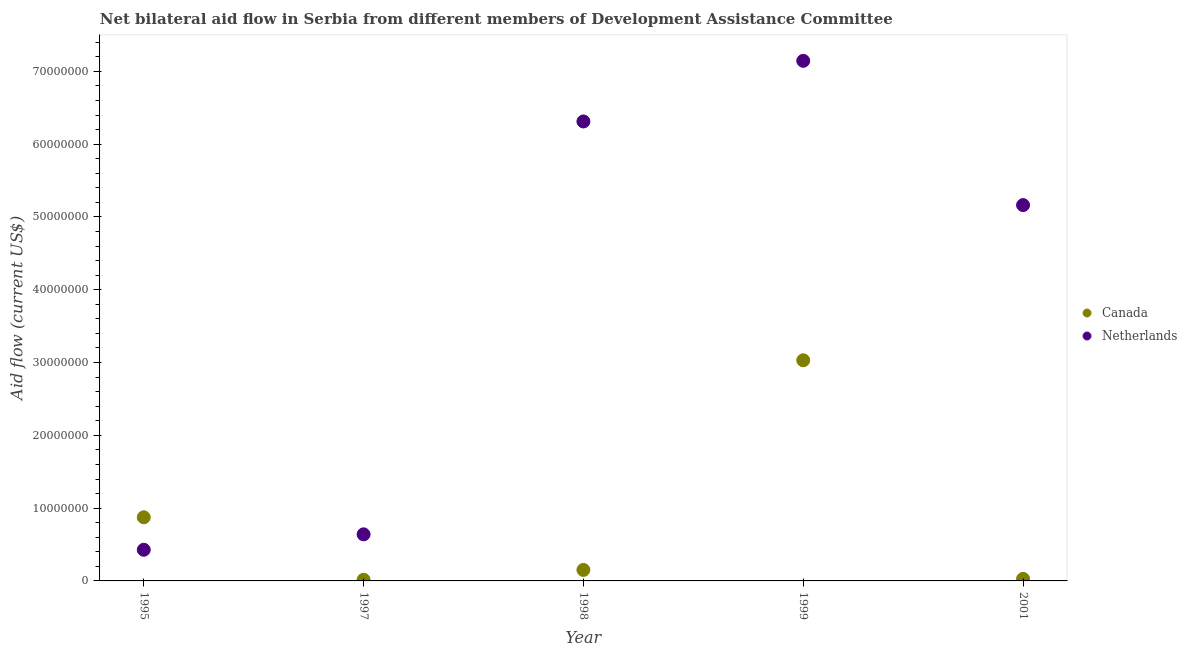How many different coloured dotlines are there?
Your answer should be very brief. 2. What is the amount of aid given by canada in 2001?
Make the answer very short. 2.80e+05. Across all years, what is the maximum amount of aid given by netherlands?
Make the answer very short. 7.14e+07. Across all years, what is the minimum amount of aid given by netherlands?
Your answer should be very brief. 4.28e+06. In which year was the amount of aid given by netherlands maximum?
Offer a terse response. 1999. In which year was the amount of aid given by canada minimum?
Ensure brevity in your answer.  1997. What is the total amount of aid given by canada in the graph?
Give a very brief answer. 4.10e+07. What is the difference between the amount of aid given by canada in 1995 and that in 2001?
Give a very brief answer. 8.46e+06. What is the difference between the amount of aid given by netherlands in 1997 and the amount of aid given by canada in 1999?
Your answer should be compact. -2.39e+07. What is the average amount of aid given by canada per year?
Provide a succinct answer. 8.20e+06. In the year 1997, what is the difference between the amount of aid given by canada and amount of aid given by netherlands?
Make the answer very short. -6.24e+06. What is the ratio of the amount of aid given by canada in 1997 to that in 1999?
Give a very brief answer. 0.01. Is the difference between the amount of aid given by canada in 1997 and 2001 greater than the difference between the amount of aid given by netherlands in 1997 and 2001?
Your answer should be very brief. Yes. What is the difference between the highest and the second highest amount of aid given by netherlands?
Make the answer very short. 8.33e+06. What is the difference between the highest and the lowest amount of aid given by netherlands?
Your answer should be very brief. 6.72e+07. Is the sum of the amount of aid given by netherlands in 1995 and 1999 greater than the maximum amount of aid given by canada across all years?
Provide a short and direct response. Yes. Is the amount of aid given by netherlands strictly greater than the amount of aid given by canada over the years?
Provide a short and direct response. No. Is the amount of aid given by netherlands strictly less than the amount of aid given by canada over the years?
Provide a short and direct response. No. How many years are there in the graph?
Offer a very short reply. 5. What is the difference between two consecutive major ticks on the Y-axis?
Make the answer very short. 1.00e+07. Are the values on the major ticks of Y-axis written in scientific E-notation?
Your answer should be compact. No. Does the graph contain any zero values?
Offer a very short reply. No. Where does the legend appear in the graph?
Provide a succinct answer. Center right. What is the title of the graph?
Your response must be concise. Net bilateral aid flow in Serbia from different members of Development Assistance Committee. What is the label or title of the X-axis?
Provide a succinct answer. Year. What is the Aid flow (current US$) in Canada in 1995?
Ensure brevity in your answer.  8.74e+06. What is the Aid flow (current US$) of Netherlands in 1995?
Your response must be concise. 4.28e+06. What is the Aid flow (current US$) in Netherlands in 1997?
Offer a terse response. 6.40e+06. What is the Aid flow (current US$) of Canada in 1998?
Offer a very short reply. 1.51e+06. What is the Aid flow (current US$) in Netherlands in 1998?
Provide a short and direct response. 6.31e+07. What is the Aid flow (current US$) of Canada in 1999?
Your answer should be very brief. 3.03e+07. What is the Aid flow (current US$) in Netherlands in 1999?
Give a very brief answer. 7.14e+07. What is the Aid flow (current US$) in Netherlands in 2001?
Offer a very short reply. 5.16e+07. Across all years, what is the maximum Aid flow (current US$) of Canada?
Ensure brevity in your answer.  3.03e+07. Across all years, what is the maximum Aid flow (current US$) of Netherlands?
Ensure brevity in your answer.  7.14e+07. Across all years, what is the minimum Aid flow (current US$) in Canada?
Your answer should be compact. 1.60e+05. Across all years, what is the minimum Aid flow (current US$) in Netherlands?
Make the answer very short. 4.28e+06. What is the total Aid flow (current US$) in Canada in the graph?
Ensure brevity in your answer.  4.10e+07. What is the total Aid flow (current US$) of Netherlands in the graph?
Make the answer very short. 1.97e+08. What is the difference between the Aid flow (current US$) of Canada in 1995 and that in 1997?
Ensure brevity in your answer.  8.58e+06. What is the difference between the Aid flow (current US$) of Netherlands in 1995 and that in 1997?
Your answer should be very brief. -2.12e+06. What is the difference between the Aid flow (current US$) of Canada in 1995 and that in 1998?
Offer a terse response. 7.23e+06. What is the difference between the Aid flow (current US$) of Netherlands in 1995 and that in 1998?
Provide a short and direct response. -5.88e+07. What is the difference between the Aid flow (current US$) in Canada in 1995 and that in 1999?
Offer a terse response. -2.16e+07. What is the difference between the Aid flow (current US$) in Netherlands in 1995 and that in 1999?
Your response must be concise. -6.72e+07. What is the difference between the Aid flow (current US$) in Canada in 1995 and that in 2001?
Keep it short and to the point. 8.46e+06. What is the difference between the Aid flow (current US$) of Netherlands in 1995 and that in 2001?
Provide a succinct answer. -4.74e+07. What is the difference between the Aid flow (current US$) of Canada in 1997 and that in 1998?
Provide a succinct answer. -1.35e+06. What is the difference between the Aid flow (current US$) of Netherlands in 1997 and that in 1998?
Keep it short and to the point. -5.67e+07. What is the difference between the Aid flow (current US$) in Canada in 1997 and that in 1999?
Offer a terse response. -3.02e+07. What is the difference between the Aid flow (current US$) in Netherlands in 1997 and that in 1999?
Give a very brief answer. -6.50e+07. What is the difference between the Aid flow (current US$) of Canada in 1997 and that in 2001?
Give a very brief answer. -1.20e+05. What is the difference between the Aid flow (current US$) of Netherlands in 1997 and that in 2001?
Your response must be concise. -4.52e+07. What is the difference between the Aid flow (current US$) of Canada in 1998 and that in 1999?
Your response must be concise. -2.88e+07. What is the difference between the Aid flow (current US$) in Netherlands in 1998 and that in 1999?
Give a very brief answer. -8.33e+06. What is the difference between the Aid flow (current US$) of Canada in 1998 and that in 2001?
Give a very brief answer. 1.23e+06. What is the difference between the Aid flow (current US$) in Netherlands in 1998 and that in 2001?
Provide a succinct answer. 1.15e+07. What is the difference between the Aid flow (current US$) of Canada in 1999 and that in 2001?
Keep it short and to the point. 3.00e+07. What is the difference between the Aid flow (current US$) in Netherlands in 1999 and that in 2001?
Offer a very short reply. 1.98e+07. What is the difference between the Aid flow (current US$) in Canada in 1995 and the Aid flow (current US$) in Netherlands in 1997?
Provide a succinct answer. 2.34e+06. What is the difference between the Aid flow (current US$) in Canada in 1995 and the Aid flow (current US$) in Netherlands in 1998?
Offer a terse response. -5.44e+07. What is the difference between the Aid flow (current US$) in Canada in 1995 and the Aid flow (current US$) in Netherlands in 1999?
Ensure brevity in your answer.  -6.27e+07. What is the difference between the Aid flow (current US$) in Canada in 1995 and the Aid flow (current US$) in Netherlands in 2001?
Give a very brief answer. -4.29e+07. What is the difference between the Aid flow (current US$) of Canada in 1997 and the Aid flow (current US$) of Netherlands in 1998?
Provide a short and direct response. -6.30e+07. What is the difference between the Aid flow (current US$) in Canada in 1997 and the Aid flow (current US$) in Netherlands in 1999?
Give a very brief answer. -7.13e+07. What is the difference between the Aid flow (current US$) of Canada in 1997 and the Aid flow (current US$) of Netherlands in 2001?
Your response must be concise. -5.15e+07. What is the difference between the Aid flow (current US$) of Canada in 1998 and the Aid flow (current US$) of Netherlands in 1999?
Your response must be concise. -6.99e+07. What is the difference between the Aid flow (current US$) in Canada in 1998 and the Aid flow (current US$) in Netherlands in 2001?
Your response must be concise. -5.01e+07. What is the difference between the Aid flow (current US$) in Canada in 1999 and the Aid flow (current US$) in Netherlands in 2001?
Ensure brevity in your answer.  -2.13e+07. What is the average Aid flow (current US$) of Canada per year?
Provide a succinct answer. 8.20e+06. What is the average Aid flow (current US$) of Netherlands per year?
Provide a short and direct response. 3.94e+07. In the year 1995, what is the difference between the Aid flow (current US$) in Canada and Aid flow (current US$) in Netherlands?
Offer a terse response. 4.46e+06. In the year 1997, what is the difference between the Aid flow (current US$) in Canada and Aid flow (current US$) in Netherlands?
Your answer should be compact. -6.24e+06. In the year 1998, what is the difference between the Aid flow (current US$) of Canada and Aid flow (current US$) of Netherlands?
Your answer should be compact. -6.16e+07. In the year 1999, what is the difference between the Aid flow (current US$) in Canada and Aid flow (current US$) in Netherlands?
Offer a very short reply. -4.11e+07. In the year 2001, what is the difference between the Aid flow (current US$) in Canada and Aid flow (current US$) in Netherlands?
Give a very brief answer. -5.14e+07. What is the ratio of the Aid flow (current US$) in Canada in 1995 to that in 1997?
Ensure brevity in your answer.  54.62. What is the ratio of the Aid flow (current US$) of Netherlands in 1995 to that in 1997?
Provide a short and direct response. 0.67. What is the ratio of the Aid flow (current US$) of Canada in 1995 to that in 1998?
Ensure brevity in your answer.  5.79. What is the ratio of the Aid flow (current US$) of Netherlands in 1995 to that in 1998?
Offer a very short reply. 0.07. What is the ratio of the Aid flow (current US$) in Canada in 1995 to that in 1999?
Your answer should be very brief. 0.29. What is the ratio of the Aid flow (current US$) of Netherlands in 1995 to that in 1999?
Provide a short and direct response. 0.06. What is the ratio of the Aid flow (current US$) of Canada in 1995 to that in 2001?
Give a very brief answer. 31.21. What is the ratio of the Aid flow (current US$) in Netherlands in 1995 to that in 2001?
Offer a terse response. 0.08. What is the ratio of the Aid flow (current US$) of Canada in 1997 to that in 1998?
Provide a succinct answer. 0.11. What is the ratio of the Aid flow (current US$) of Netherlands in 1997 to that in 1998?
Your answer should be compact. 0.1. What is the ratio of the Aid flow (current US$) of Canada in 1997 to that in 1999?
Provide a succinct answer. 0.01. What is the ratio of the Aid flow (current US$) of Netherlands in 1997 to that in 1999?
Make the answer very short. 0.09. What is the ratio of the Aid flow (current US$) in Netherlands in 1997 to that in 2001?
Provide a short and direct response. 0.12. What is the ratio of the Aid flow (current US$) of Canada in 1998 to that in 1999?
Keep it short and to the point. 0.05. What is the ratio of the Aid flow (current US$) in Netherlands in 1998 to that in 1999?
Ensure brevity in your answer.  0.88. What is the ratio of the Aid flow (current US$) of Canada in 1998 to that in 2001?
Keep it short and to the point. 5.39. What is the ratio of the Aid flow (current US$) in Netherlands in 1998 to that in 2001?
Your response must be concise. 1.22. What is the ratio of the Aid flow (current US$) of Canada in 1999 to that in 2001?
Offer a very short reply. 108.25. What is the ratio of the Aid flow (current US$) of Netherlands in 1999 to that in 2001?
Provide a short and direct response. 1.38. What is the difference between the highest and the second highest Aid flow (current US$) of Canada?
Make the answer very short. 2.16e+07. What is the difference between the highest and the second highest Aid flow (current US$) of Netherlands?
Offer a very short reply. 8.33e+06. What is the difference between the highest and the lowest Aid flow (current US$) of Canada?
Your answer should be compact. 3.02e+07. What is the difference between the highest and the lowest Aid flow (current US$) in Netherlands?
Keep it short and to the point. 6.72e+07. 